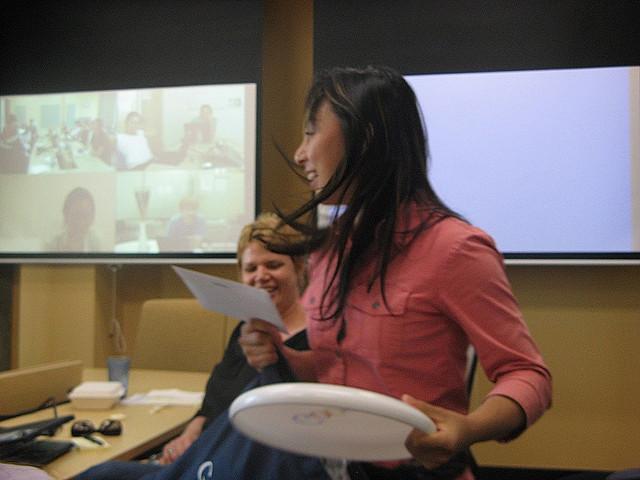What is on the women's face?
Be succinct. Smile. What is the theme of the cake?
Concise answer only. No cake. What is in the woman's hand?
Quick response, please. Frisbee. Where are the woman's hands?
Concise answer only. Frisbee. What room is she in?
Write a very short answer. Conference. What channel is the woman watching on the TV?
Short answer required. Cnn. How many girls are present?
Concise answer only. 2. What does it say on the projector screen?
Keep it brief. Nothing. Is the woman angry?
Give a very brief answer. No. What color hair does the woman in the red shirt have?
Short answer required. Black. What color is she?
Be succinct. Brown. How many women are in the picture?
Be succinct. 2. Is she a "home cook"?
Quick response, please. No. Is this picture taken in someone's house?
Quick response, please. No. What is in the person's hand?
Quick response, please. Frisbee. 